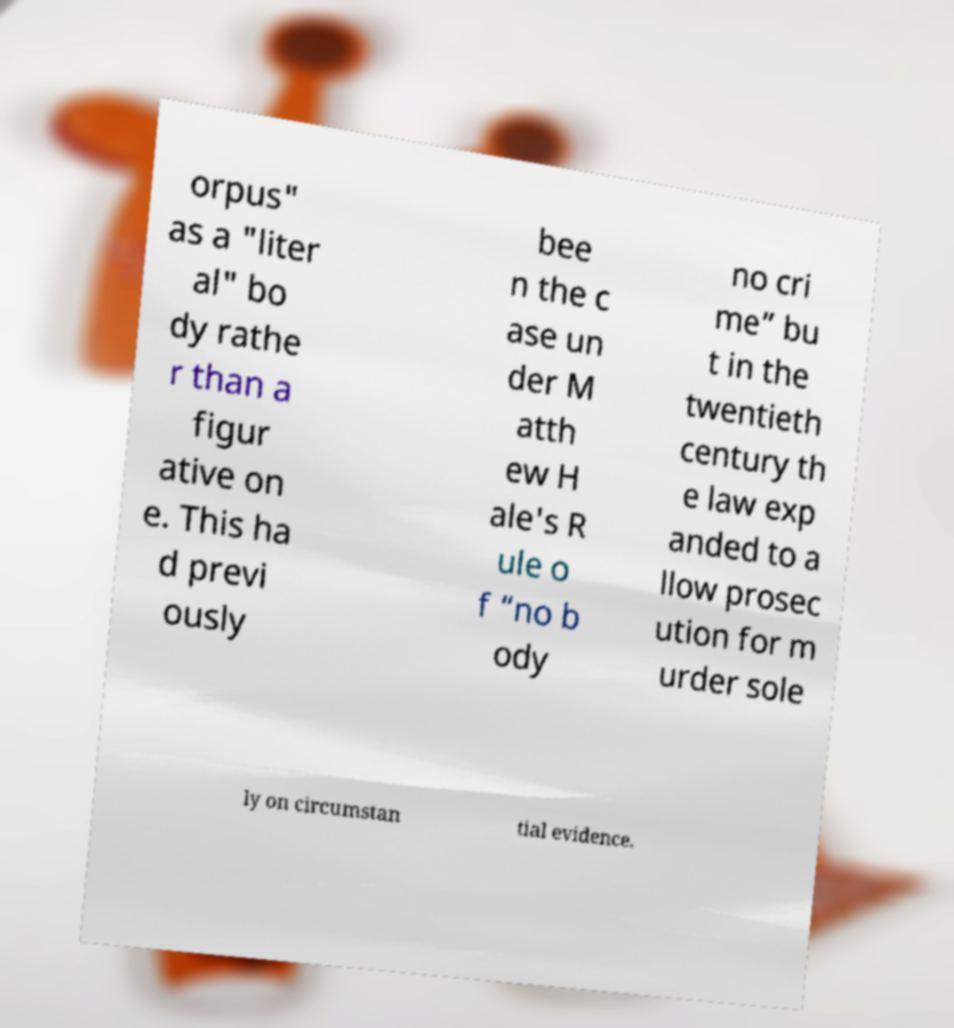Could you extract and type out the text from this image? orpus" as a "liter al" bo dy rathe r than a figur ative on e. This ha d previ ously bee n the c ase un der M atth ew H ale's R ule o f “no b ody no cri me” bu t in the twentieth century th e law exp anded to a llow prosec ution for m urder sole ly on circumstan tial evidence. 